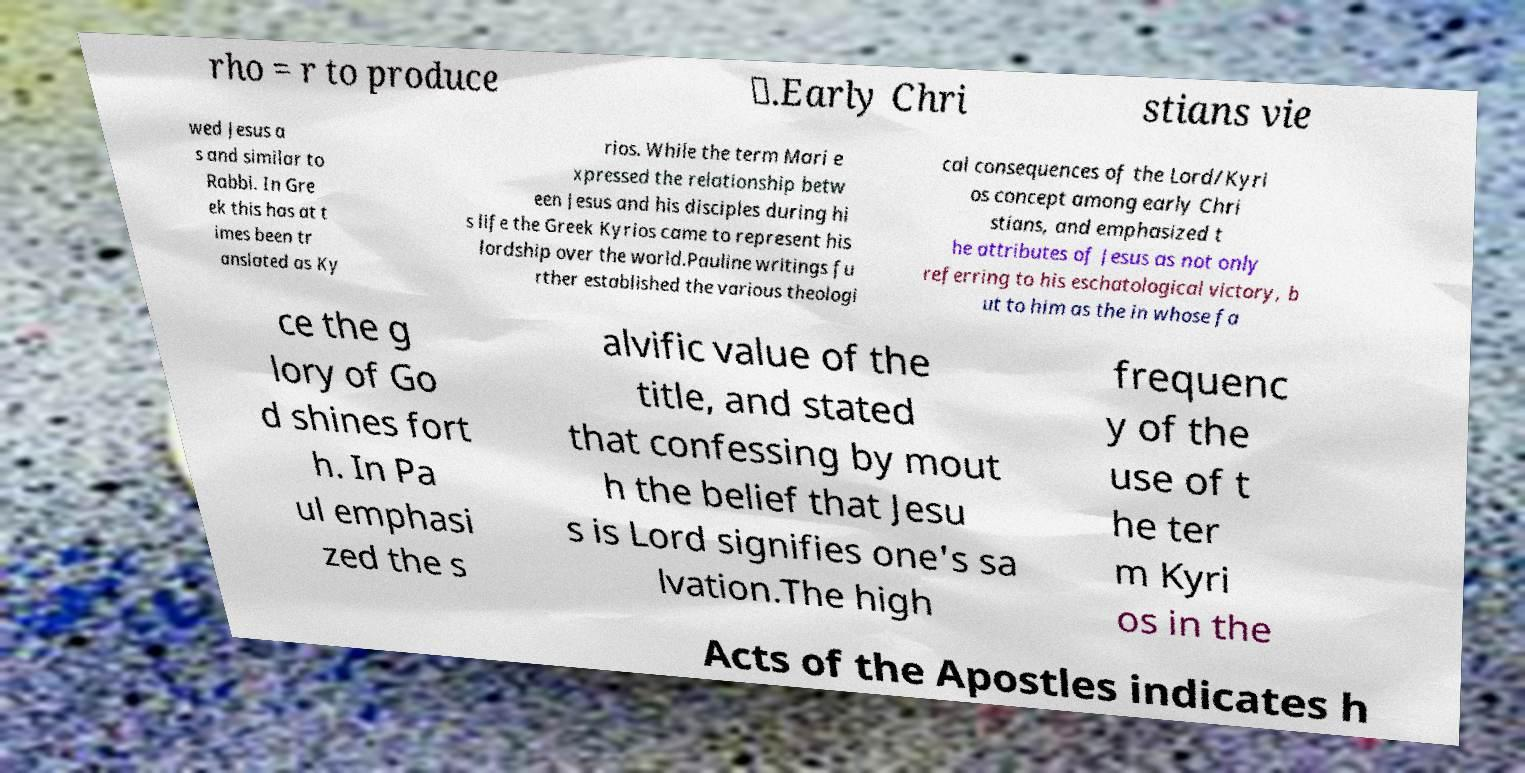Please identify and transcribe the text found in this image. rho = r to produce ☧.Early Chri stians vie wed Jesus a s and similar to Rabbi. In Gre ek this has at t imes been tr anslated as Ky rios. While the term Mari e xpressed the relationship betw een Jesus and his disciples during hi s life the Greek Kyrios came to represent his lordship over the world.Pauline writings fu rther established the various theologi cal consequences of the Lord/Kyri os concept among early Chri stians, and emphasized t he attributes of Jesus as not only referring to his eschatological victory, b ut to him as the in whose fa ce the g lory of Go d shines fort h. In Pa ul emphasi zed the s alvific value of the title, and stated that confessing by mout h the belief that Jesu s is Lord signifies one's sa lvation.The high frequenc y of the use of t he ter m Kyri os in the Acts of the Apostles indicates h 